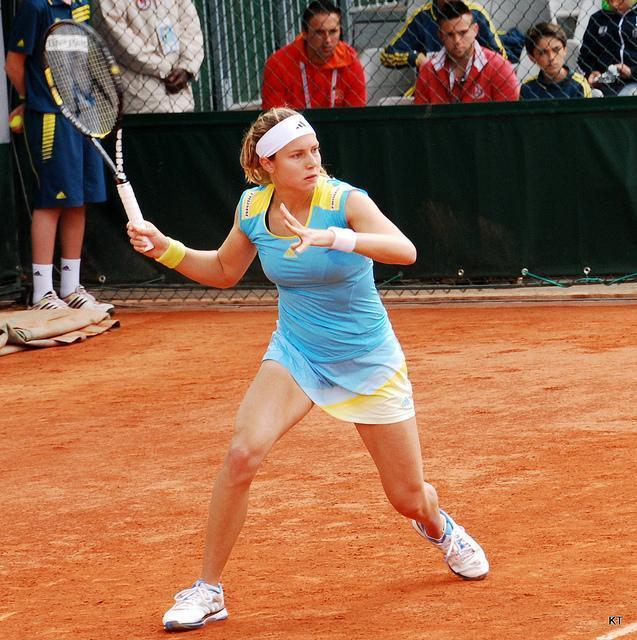How many people are in the picture?
Give a very brief answer. 8. 